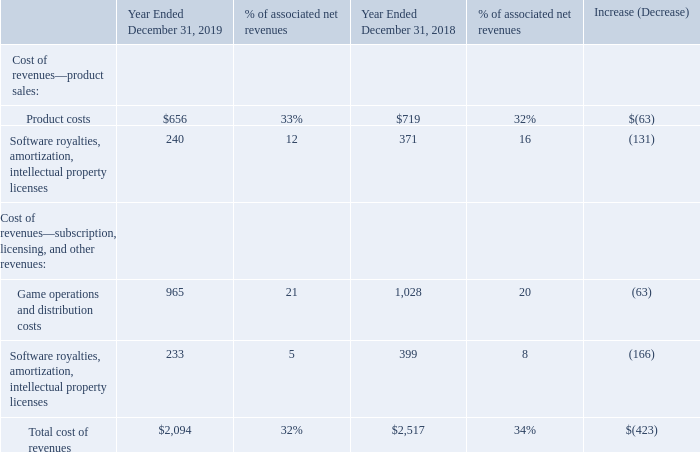Costs and Expenses
Cost of Revenues
The following tables detail the components of cost of revenues in dollars (amounts in millions) and as a percentage of associated net revenues:
Cost of Revenues—Product Sales:
The decrease in product costs for 2019, as compared to 2018, was due to the decrease in product sales, primarily associated with the Destiny franchise (reflecting our sale of the publishing rights for Destiny to Bungie in December 2018).
The decrease in software royalties, amortization, and intellectual property licenses related to product sales for 2019, as compared to 2018, was primarily due to a decrease of $133 million in software amortization and royalties from Activision, primarily due to the Destiny franchise. The decrease was partially offset by:
higher software amortization and royalties for Call of Duty: Black Ops 4, which was released in October 2018, as compared to Call of Duty: WWII, which was released in November 2017; software amortization and royalties from Sekiro: Shadows Die Twice, which was released in March 2019; and higher software amortization and royalties for Call of Duty: Modern Warfare, which was released in October 2019, as compared to Call of Duty: Black Ops 4.
Cost of Revenues—Subscription, Licensing, and Other Revenues:
The decrease in game operations and distribution costs for 2019, as compared to 2018, was primarily due to a decrease of $50 million in service provider fees such as digital storefront fees (e.g., fees retained by Apple and Google for our sales on their platforms), payment processor fees, and server bandwidth fees.
The decrease in software royalties, amortization, and intellectual property licenses related to subscription, licensing, and other revenues for 2019, as compared to 2018, was primarily due to:
a decrease of $122 million in amortization of internally-developed franchise intangible assets acquired as part of our acquisition of King; a decrease of $36 million in software amortization and royalties from Activision, driven by the Destiny franchise, partially offset by software royalties on Call of Duty: Mobile, which was released in October 2019; and  lower amortization of capitalized film costs due to the release of the third season of the animated TV series, Skylanders™ Academy, in September 2018, with no comparable release in 2019.
What were the product costs in 2019?
Answer scale should be: million. 656. What were the game operations and distribution costs in 2019?
Answer scale should be: million. 965. What was the total cost of revenues in 2018?
Answer scale should be: million. 2,517. What is the percentage change in product costs between 2018 and 2019?
Answer scale should be: percent. (656-719)/719
Answer: -8.76. What is the percentage change in game operations and distribution costs between 2018 and 2019?
Answer scale should be: percent. (965-1,028)/1,028
Answer: -6.13. What percentage of total cost of revenues in 2019 consists of product costs?
Answer scale should be: percent. (656/$2,094)
Answer: 31.33. 